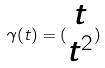<formula> <loc_0><loc_0><loc_500><loc_500>\gamma ( t ) = ( \begin{matrix} t \\ t ^ { 2 } \end{matrix} )</formula> 